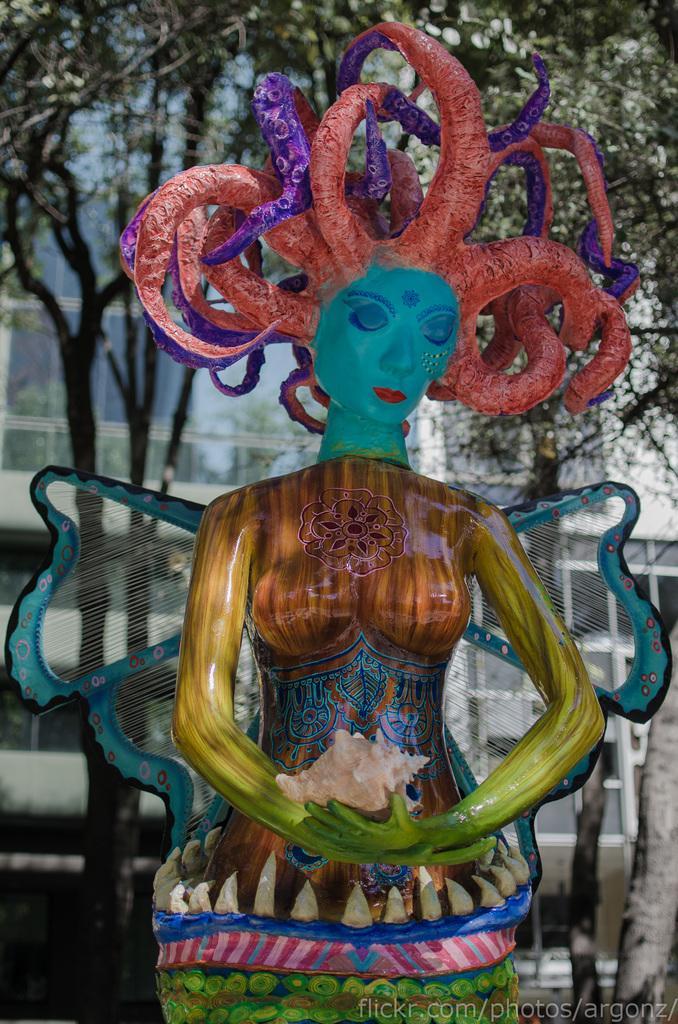How would you summarize this image in a sentence or two? In this image there is a colorful statue of a woman holding a shell. In the background there are buildings, trees. 